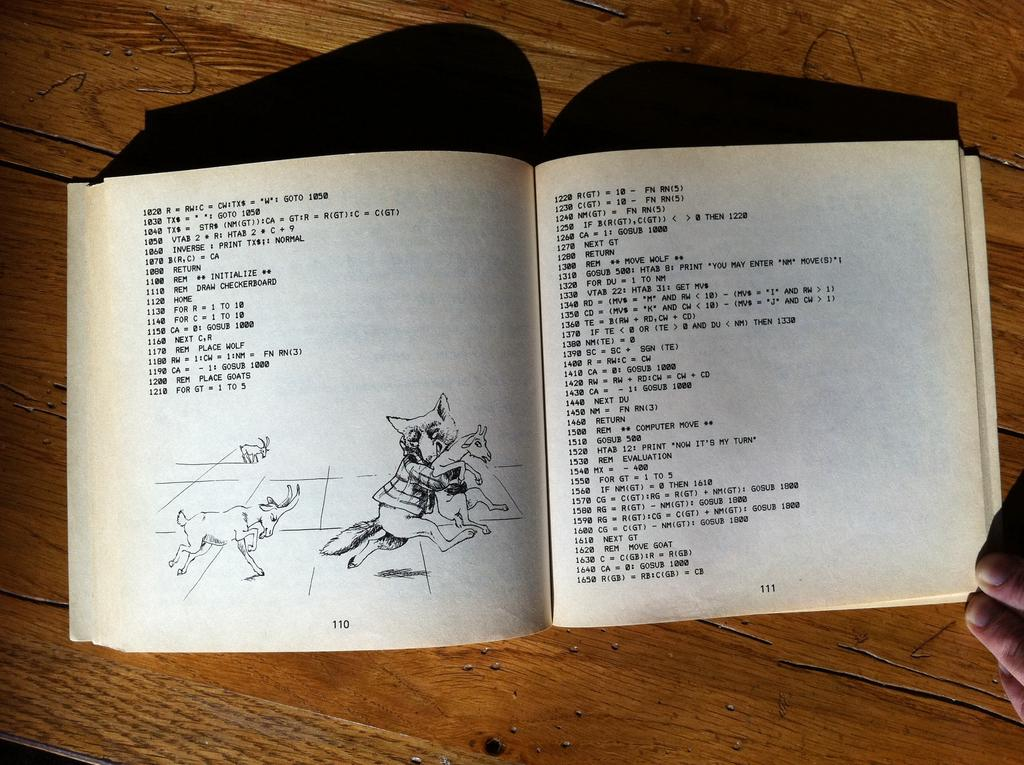What is the main object in the image? There is an opened book in the image. What can be seen on the pages of the book? The book has an image and writing on it. Where is the book located? The book is placed on a table. Can you see any part of a person in the image? Yes, there are fingers of a person in the right corner of the image. What type of stitch is being used to repair the umbrella in the image? There is no umbrella present in the image, and therefore no stitching can be observed. 